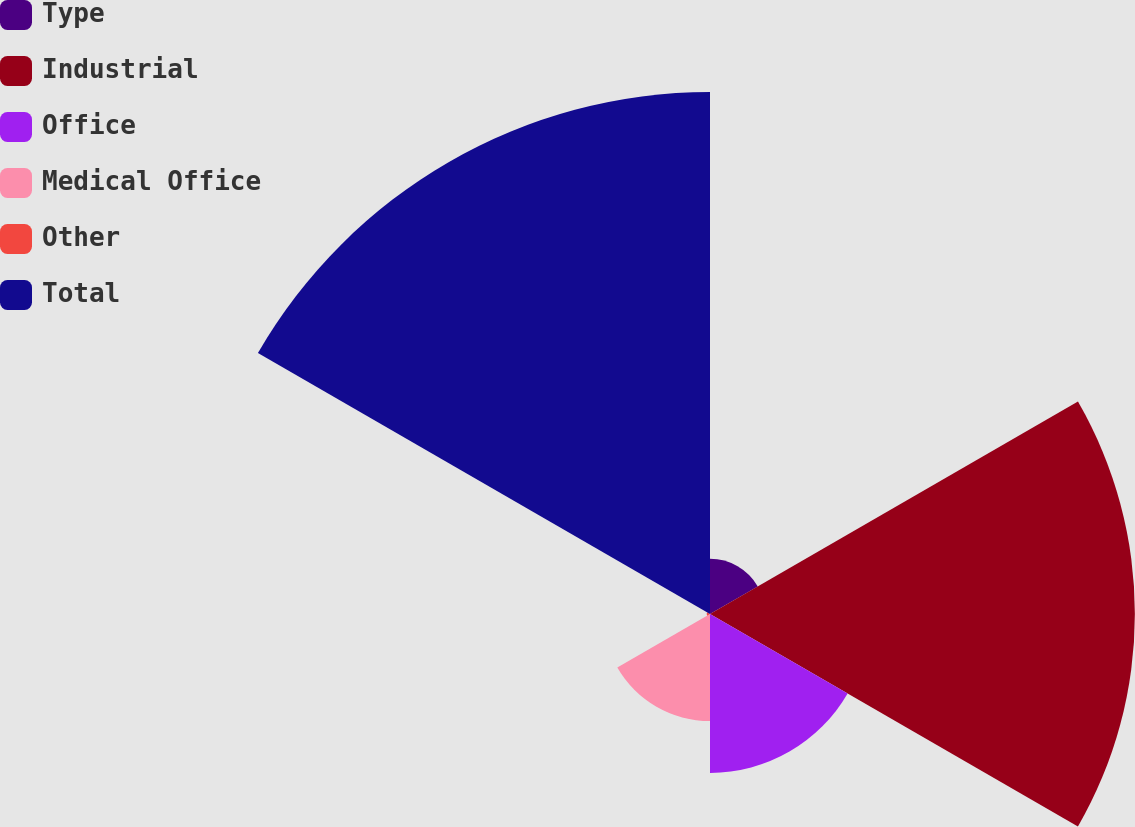<chart> <loc_0><loc_0><loc_500><loc_500><pie_chart><fcel>Type<fcel>Industrial<fcel>Office<fcel>Medical Office<fcel>Other<fcel>Total<nl><fcel>4.34%<fcel>33.42%<fcel>12.5%<fcel>8.42%<fcel>0.26%<fcel>41.06%<nl></chart> 